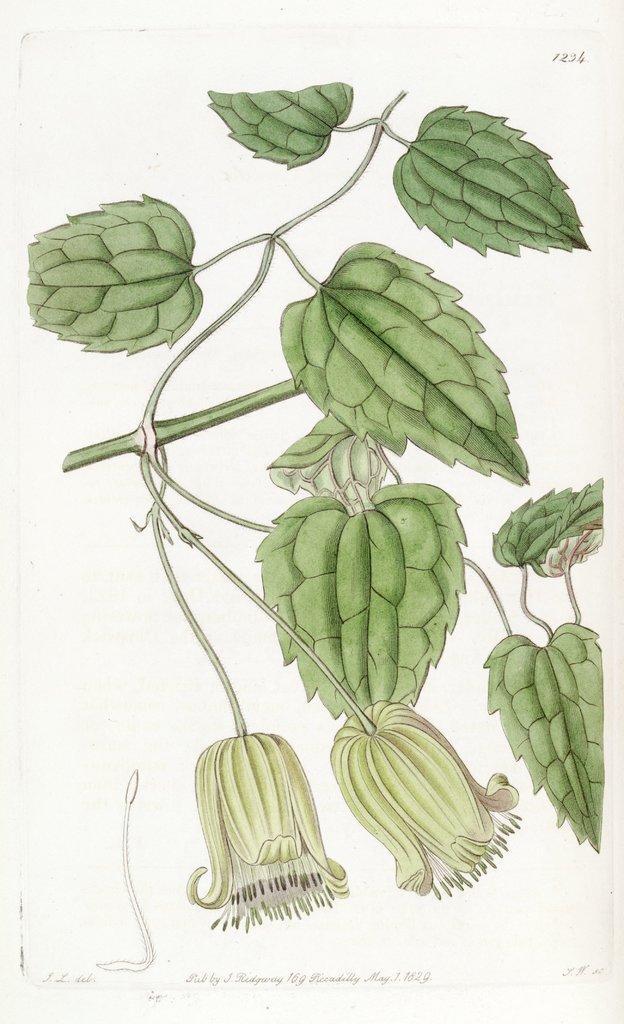Please provide a concise description of this image. In this image there is a painting of green leaves and flowers to the stem. 